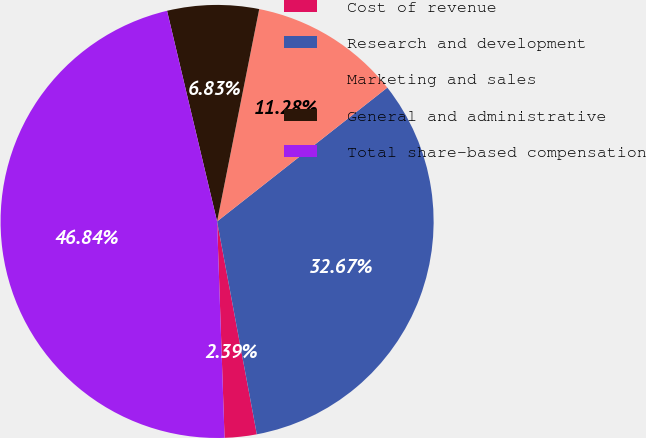Convert chart. <chart><loc_0><loc_0><loc_500><loc_500><pie_chart><fcel>Cost of revenue<fcel>Research and development<fcel>Marketing and sales<fcel>General and administrative<fcel>Total share-based compensation<nl><fcel>2.39%<fcel>32.67%<fcel>11.28%<fcel>6.83%<fcel>46.84%<nl></chart> 